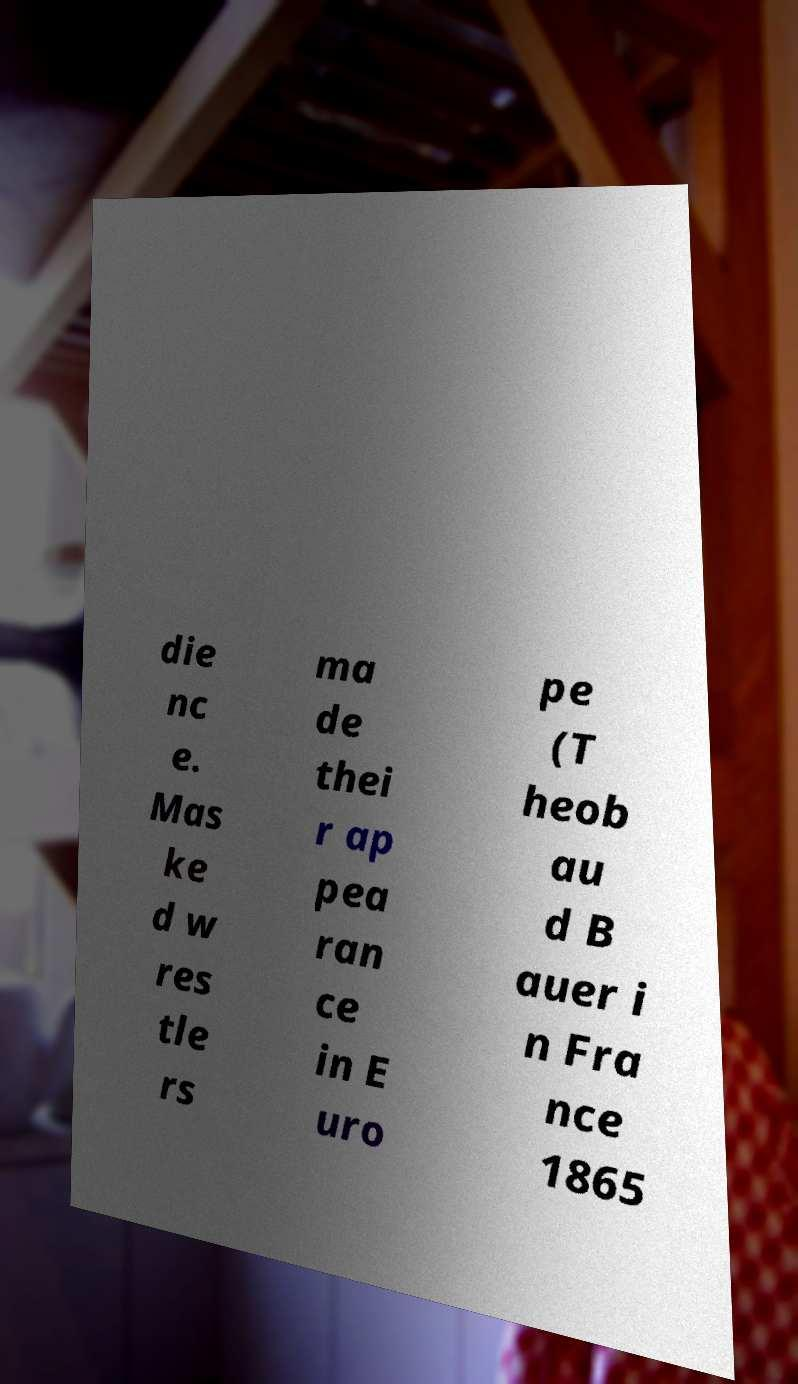Please read and relay the text visible in this image. What does it say? die nc e. Mas ke d w res tle rs ma de thei r ap pea ran ce in E uro pe (T heob au d B auer i n Fra nce 1865 